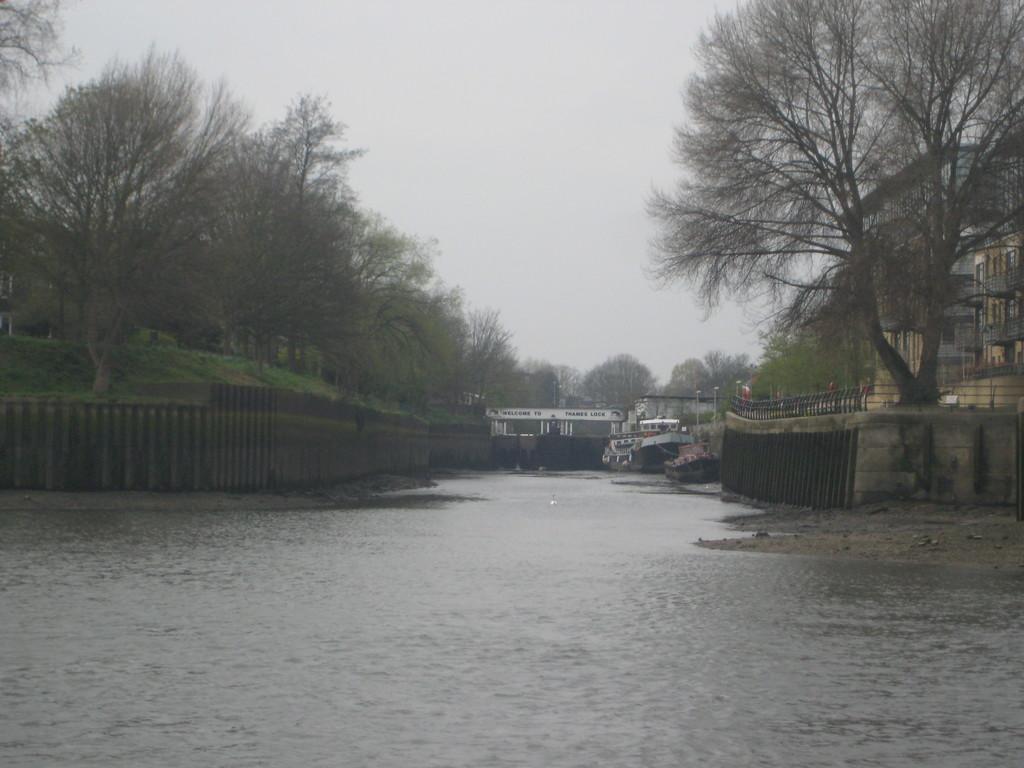Could you give a brief overview of what you see in this image? In this image I can see a water,few boats and a fencing on both-sides. I can see a trees,buildings,windows and poles. The sky is in white color. 